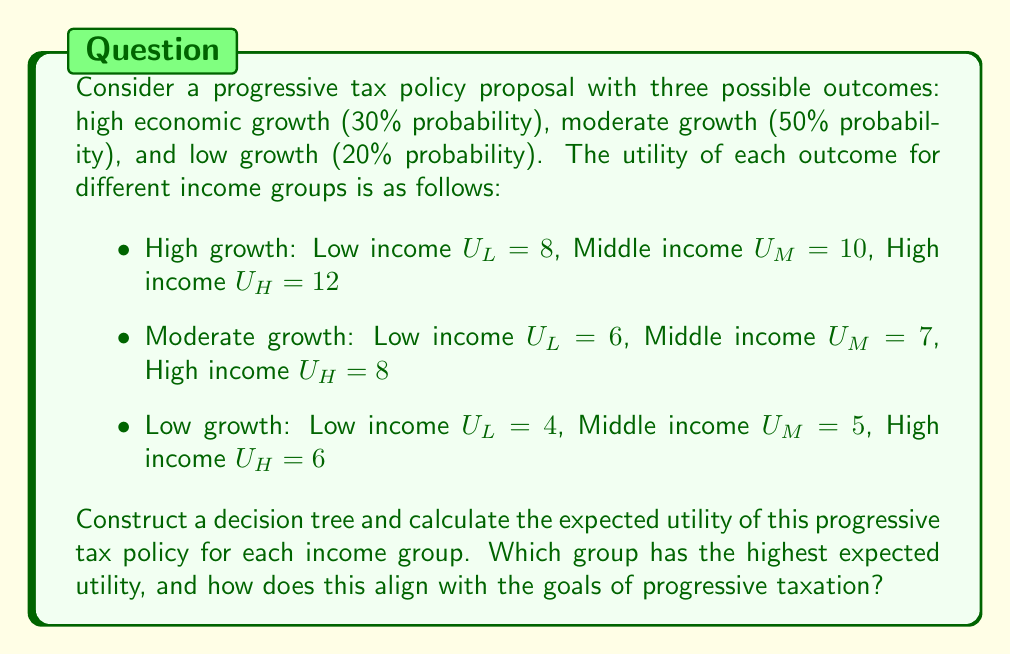Help me with this question. To solve this problem, we'll construct a decision tree and calculate the expected utility for each income group.

1. Construct the decision tree:

[asy]
unitsize(1cm);

draw((0,0)--(2,2), arrow=Arrow);
draw((0,0)--(2,0), arrow=Arrow);
draw((0,0)--(2,-2), arrow=Arrow);

label("High growth (0.3)", (1,1.5), E);
label("Moderate growth (0.5)", (1,0), E);
label("Low growth (0.2)", (1,-1.5), E);

label("Progressive Tax Policy", (-1,0), W);

dot((0,0));
dot((2,2));
dot((2,0));
dot((2,-2));
[/asy]

2. Calculate expected utility for each income group:

For each group, we'll use the formula:
$$E(U) = \sum_{i=1}^n p_i \cdot U_i$$

Where $p_i$ is the probability of each outcome, and $U_i$ is the utility for that outcome.

Low income group:
$$E(U_L) = 0.3 \cdot 8 + 0.5 \cdot 6 + 0.2 \cdot 4$$
$$E(U_L) = 2.4 + 3.0 + 0.8 = 6.2$$

Middle income group:
$$E(U_M) = 0.3 \cdot 10 + 0.5 \cdot 7 + 0.2 \cdot 5$$
$$E(U_M) = 3.0 + 3.5 + 1.0 = 7.5$$

High income group:
$$E(U_H) = 0.3 \cdot 12 + 0.5 \cdot 8 + 0.2 \cdot 6$$
$$E(U_H) = 3.6 + 4.0 + 1.2 = 8.8$$

3. Compare expected utilities:

The high income group has the highest expected utility (8.8), followed by the middle income group (7.5), and then the low income group (6.2).

4. Alignment with progressive taxation goals:

Progressive taxation aims to reduce income inequality by imposing higher tax rates on higher-income individuals. In this scenario, while the high-income group still has the highest expected utility, the difference between the groups is smaller than the difference in their utilities for each individual outcome. This suggests that the progressive tax policy has some equalizing effect, but may not fully achieve the goal of reducing income inequality.

As a liberal economist, you might argue that this policy doesn't go far enough in redistributing utility across income groups. However, you might also be cautious about pushing for more aggressive policies, considering the potential economic growth implications and the need to balance equity with efficiency.
Answer: The expected utilities for each income group are:
Low income: 6.2
Middle income: 7.5
High income: 8.8

The high income group has the highest expected utility. While this aligns with the general income distribution, the progressive tax policy appears to have a moderate equalizing effect, as the differences in expected utilities are smaller than the differences in individual outcome utilities. However, a more aggressive policy might be needed to further reduce income inequality, balancing this goal with economic growth considerations. 